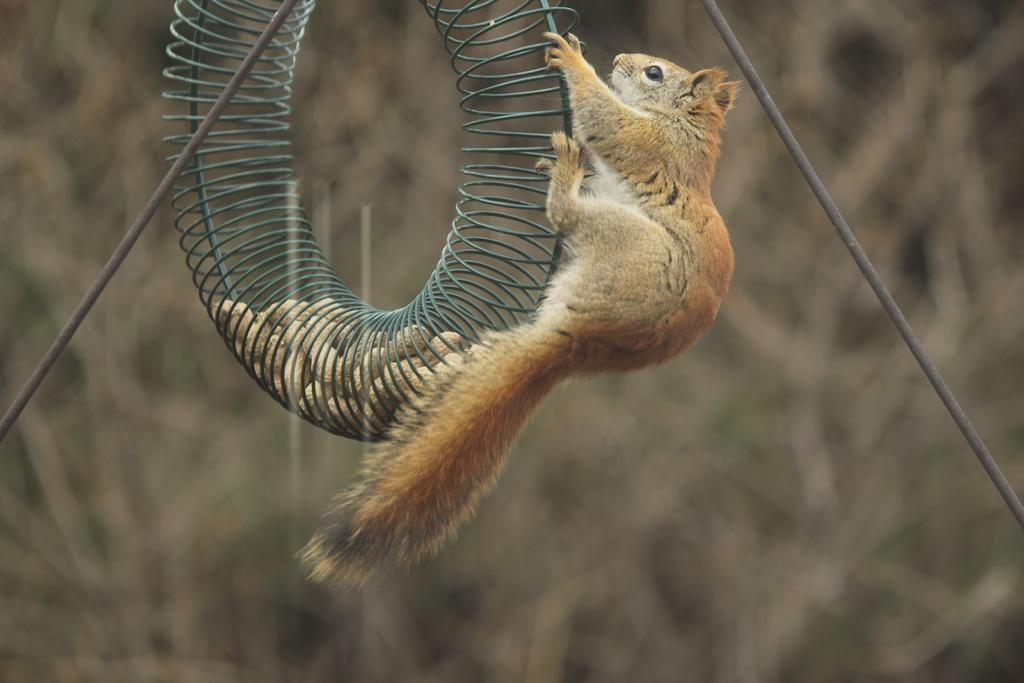What animal can be seen in the image? There is a squirrel in the image. What is the squirrel doing in the image? The squirrel is climbing a ring. What other objects are present in the image? There are rods in the image. Can you describe the background of the image? The background of the image is blurry. What type of fowl can be seen flying in the image? There is no fowl present in the image; it features a squirrel climbing a ring. What is the squirrel using to cut the rods in the image? There is no knife or cutting action depicted in the image; the squirrel is simply climbing a ring. 